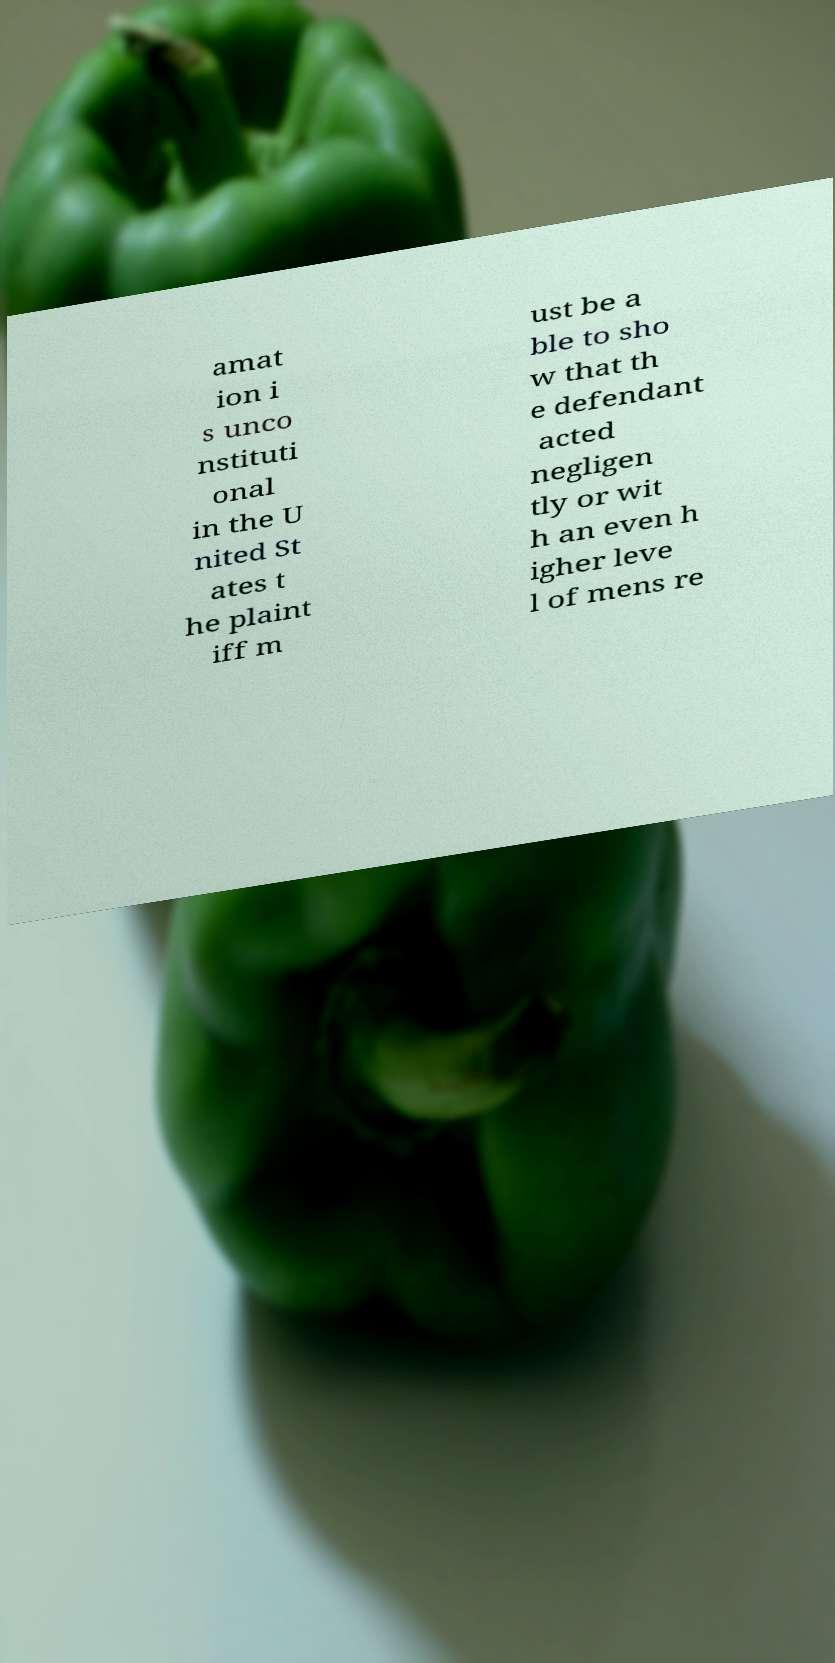Can you accurately transcribe the text from the provided image for me? amat ion i s unco nstituti onal in the U nited St ates t he plaint iff m ust be a ble to sho w that th e defendant acted negligen tly or wit h an even h igher leve l of mens re 